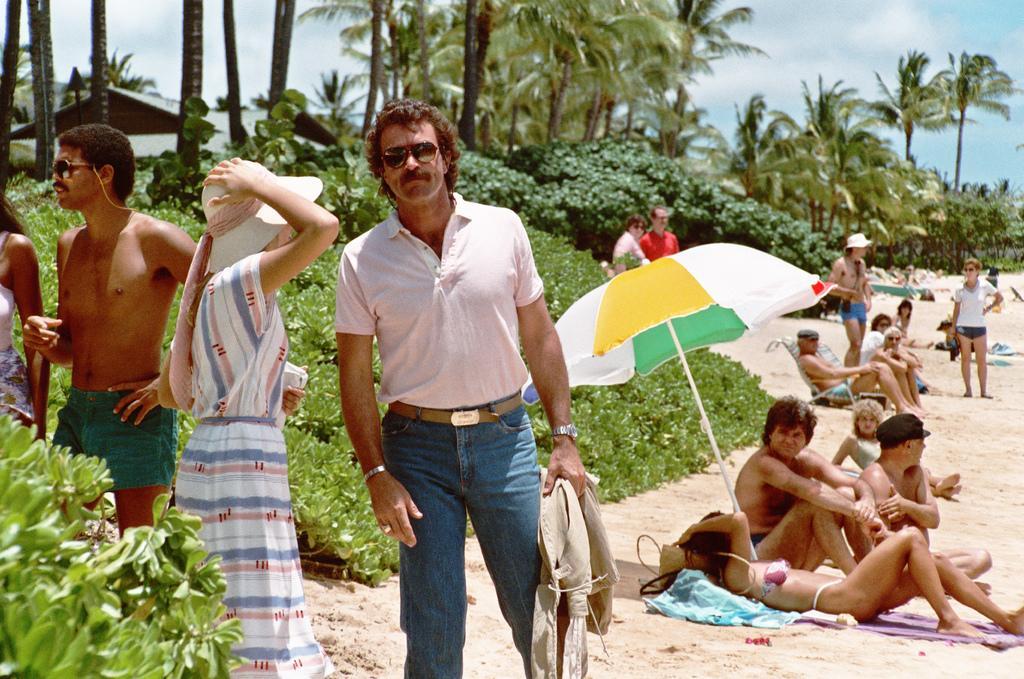Could you give a brief overview of what you see in this image? In front of the image there are a few people standing, behind them there are a few people lay on the sand, behind them there are trees. 